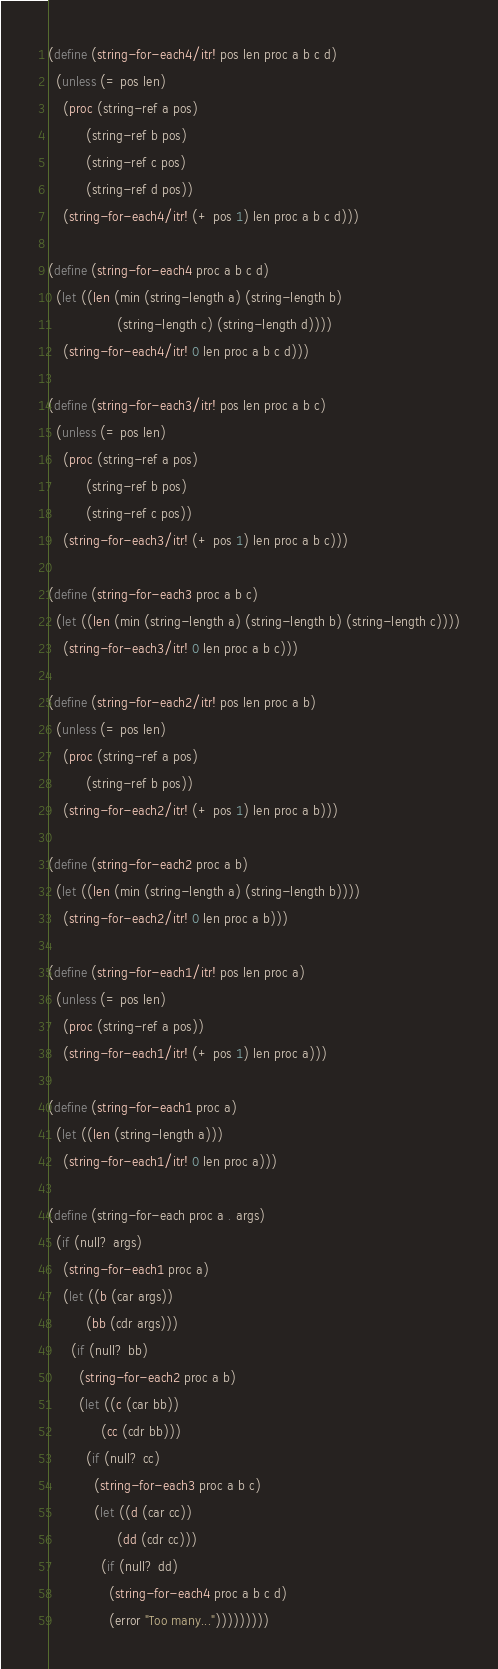<code> <loc_0><loc_0><loc_500><loc_500><_Scheme_>(define (string-for-each4/itr! pos len proc a b c d)
  (unless (= pos len)
    (proc (string-ref a pos)
          (string-ref b pos)
          (string-ref c pos)
          (string-ref d pos))
    (string-for-each4/itr! (+ pos 1) len proc a b c d)))

(define (string-for-each4 proc a b c d)
  (let ((len (min (string-length a) (string-length b)
                  (string-length c) (string-length d))))
    (string-for-each4/itr! 0 len proc a b c d)))

(define (string-for-each3/itr! pos len proc a b c)
  (unless (= pos len)
    (proc (string-ref a pos)
          (string-ref b pos)
          (string-ref c pos))
    (string-for-each3/itr! (+ pos 1) len proc a b c)))

(define (string-for-each3 proc a b c)
  (let ((len (min (string-length a) (string-length b) (string-length c))))
    (string-for-each3/itr! 0 len proc a b c)))

(define (string-for-each2/itr! pos len proc a b)
  (unless (= pos len)
    (proc (string-ref a pos)
          (string-ref b pos))
    (string-for-each2/itr! (+ pos 1) len proc a b)))

(define (string-for-each2 proc a b)
  (let ((len (min (string-length a) (string-length b))))
    (string-for-each2/itr! 0 len proc a b)))

(define (string-for-each1/itr! pos len proc a)
  (unless (= pos len)
    (proc (string-ref a pos))
    (string-for-each1/itr! (+ pos 1) len proc a)))

(define (string-for-each1 proc a)
  (let ((len (string-length a)))
    (string-for-each1/itr! 0 len proc a)))

(define (string-for-each proc a . args)
  (if (null? args)
    (string-for-each1 proc a)
    (let ((b (car args))
          (bb (cdr args)))
      (if (null? bb)
        (string-for-each2 proc a b)
        (let ((c (car bb))
              (cc (cdr bb)))
          (if (null? cc)
            (string-for-each3 proc a b c)
            (let ((d (car cc))
                  (dd (cdr cc)))
              (if (null? dd)
                (string-for-each4 proc a b c d)
                (error "Too many...")))))))))
</code> 